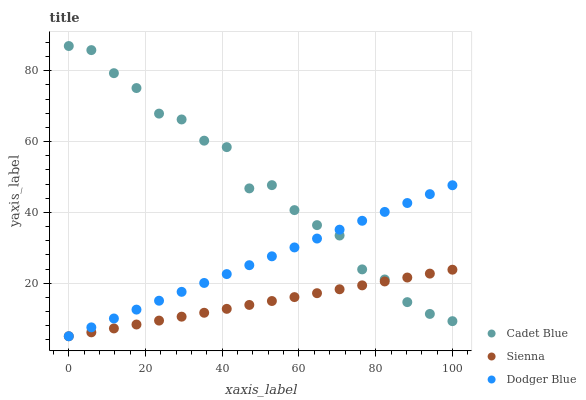Does Sienna have the minimum area under the curve?
Answer yes or no. Yes. Does Cadet Blue have the maximum area under the curve?
Answer yes or no. Yes. Does Dodger Blue have the minimum area under the curve?
Answer yes or no. No. Does Dodger Blue have the maximum area under the curve?
Answer yes or no. No. Is Sienna the smoothest?
Answer yes or no. Yes. Is Cadet Blue the roughest?
Answer yes or no. Yes. Is Dodger Blue the smoothest?
Answer yes or no. No. Is Dodger Blue the roughest?
Answer yes or no. No. Does Sienna have the lowest value?
Answer yes or no. Yes. Does Cadet Blue have the lowest value?
Answer yes or no. No. Does Cadet Blue have the highest value?
Answer yes or no. Yes. Does Dodger Blue have the highest value?
Answer yes or no. No. Does Dodger Blue intersect Cadet Blue?
Answer yes or no. Yes. Is Dodger Blue less than Cadet Blue?
Answer yes or no. No. Is Dodger Blue greater than Cadet Blue?
Answer yes or no. No. 